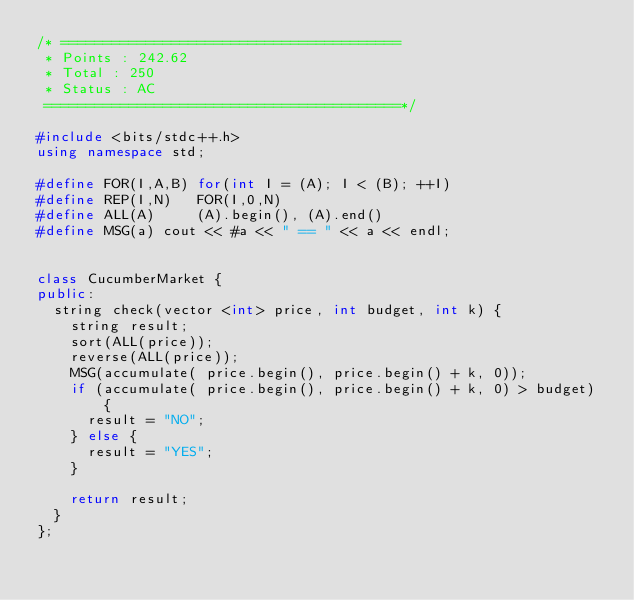Convert code to text. <code><loc_0><loc_0><loc_500><loc_500><_C++_>/* ========================================
 * Points : 242.62
 * Total : 250
 * Status : AC
 ==========================================*/

#include <bits/stdc++.h>
using namespace std;

#define FOR(I,A,B) for(int I = (A); I < (B); ++I)
#define REP(I,N)   FOR(I,0,N)
#define ALL(A)     (A).begin(), (A).end()
#define MSG(a) cout << #a << " == " << a << endl;


class CucumberMarket {
public:
  string check(vector <int> price, int budget, int k) {
    string result;
    sort(ALL(price));
    reverse(ALL(price));
    MSG(accumulate( price.begin(), price.begin() + k, 0));
    if (accumulate( price.begin(), price.begin() + k, 0) > budget) {
      result = "NO";
    } else {
      result = "YES";
    }

    return result;
  }
};
</code> 